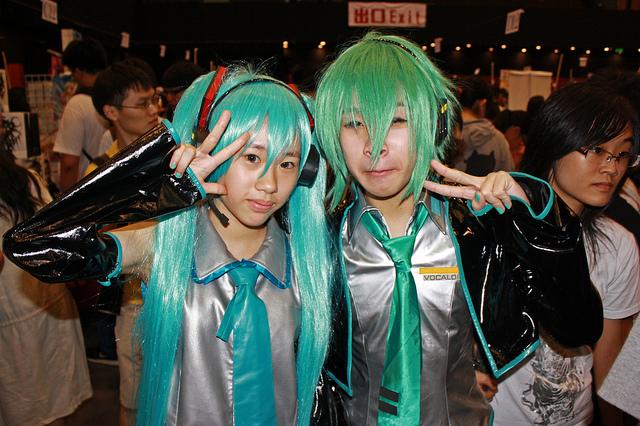Are the wigs realistic?
Keep it brief. No. Are they wearing wigs?
Short answer required. Yes. What color are their shirts?
Answer briefly. Silver. 